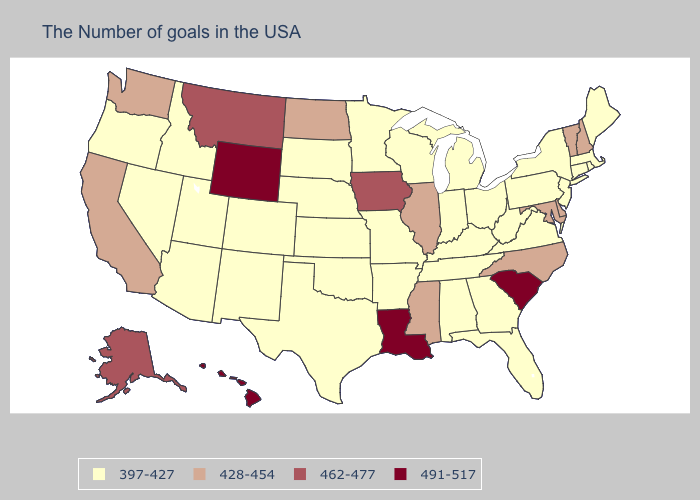Does New Hampshire have the same value as Michigan?
Concise answer only. No. Does South Dakota have the same value as Delaware?
Quick response, please. No. What is the highest value in the MidWest ?
Be succinct. 462-477. Does Illinois have the highest value in the MidWest?
Give a very brief answer. No. Name the states that have a value in the range 428-454?
Write a very short answer. New Hampshire, Vermont, Delaware, Maryland, North Carolina, Illinois, Mississippi, North Dakota, California, Washington. What is the value of Kansas?
Write a very short answer. 397-427. Name the states that have a value in the range 491-517?
Answer briefly. South Carolina, Louisiana, Wyoming, Hawaii. Name the states that have a value in the range 428-454?
Write a very short answer. New Hampshire, Vermont, Delaware, Maryland, North Carolina, Illinois, Mississippi, North Dakota, California, Washington. What is the highest value in states that border Wyoming?
Concise answer only. 462-477. Name the states that have a value in the range 397-427?
Give a very brief answer. Maine, Massachusetts, Rhode Island, Connecticut, New York, New Jersey, Pennsylvania, Virginia, West Virginia, Ohio, Florida, Georgia, Michigan, Kentucky, Indiana, Alabama, Tennessee, Wisconsin, Missouri, Arkansas, Minnesota, Kansas, Nebraska, Oklahoma, Texas, South Dakota, Colorado, New Mexico, Utah, Arizona, Idaho, Nevada, Oregon. Name the states that have a value in the range 462-477?
Keep it brief. Iowa, Montana, Alaska. What is the highest value in the South ?
Concise answer only. 491-517. 